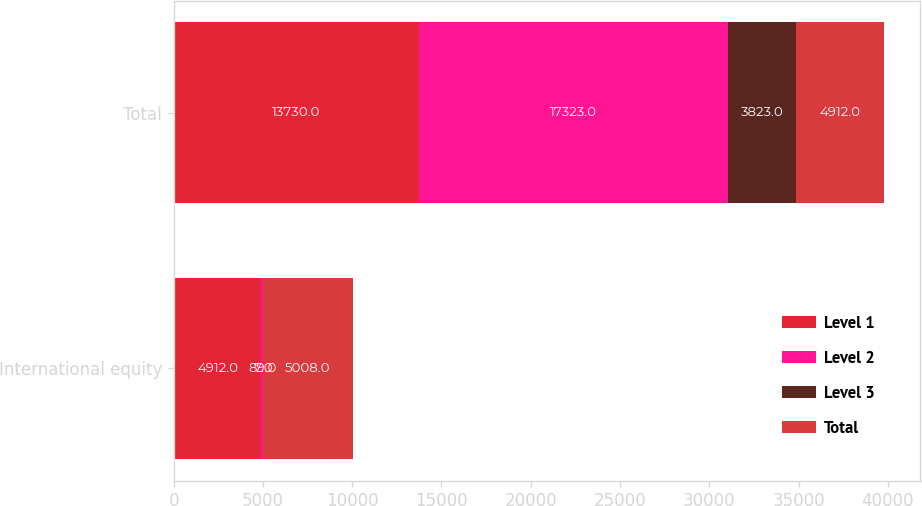Convert chart to OTSL. <chart><loc_0><loc_0><loc_500><loc_500><stacked_bar_chart><ecel><fcel>International equity<fcel>Total<nl><fcel>Level 1<fcel>4912<fcel>13730<nl><fcel>Level 2<fcel>89<fcel>17323<nl><fcel>Level 3<fcel>7<fcel>3823<nl><fcel>Total<fcel>5008<fcel>4912<nl></chart> 